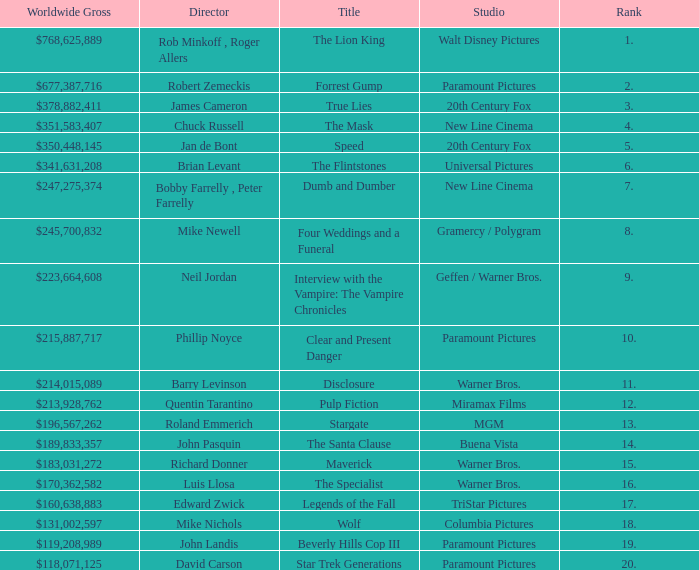Help me parse the entirety of this table. {'header': ['Worldwide Gross', 'Director', 'Title', 'Studio', 'Rank'], 'rows': [['$768,625,889', 'Rob Minkoff , Roger Allers', 'The Lion King', 'Walt Disney Pictures', '1.'], ['$677,387,716', 'Robert Zemeckis', 'Forrest Gump', 'Paramount Pictures', '2.'], ['$378,882,411', 'James Cameron', 'True Lies', '20th Century Fox', '3.'], ['$351,583,407', 'Chuck Russell', 'The Mask', 'New Line Cinema', '4.'], ['$350,448,145', 'Jan de Bont', 'Speed', '20th Century Fox', '5.'], ['$341,631,208', 'Brian Levant', 'The Flintstones', 'Universal Pictures', '6.'], ['$247,275,374', 'Bobby Farrelly , Peter Farrelly', 'Dumb and Dumber', 'New Line Cinema', '7.'], ['$245,700,832', 'Mike Newell', 'Four Weddings and a Funeral', 'Gramercy / Polygram', '8.'], ['$223,664,608', 'Neil Jordan', 'Interview with the Vampire: The Vampire Chronicles', 'Geffen / Warner Bros.', '9.'], ['$215,887,717', 'Phillip Noyce', 'Clear and Present Danger', 'Paramount Pictures', '10.'], ['$214,015,089', 'Barry Levinson', 'Disclosure', 'Warner Bros.', '11.'], ['$213,928,762', 'Quentin Tarantino', 'Pulp Fiction', 'Miramax Films', '12.'], ['$196,567,262', 'Roland Emmerich', 'Stargate', 'MGM', '13.'], ['$189,833,357', 'John Pasquin', 'The Santa Clause', 'Buena Vista', '14.'], ['$183,031,272', 'Richard Donner', 'Maverick', 'Warner Bros.', '15.'], ['$170,362,582', 'Luis Llosa', 'The Specialist', 'Warner Bros.', '16.'], ['$160,638,883', 'Edward Zwick', 'Legends of the Fall', 'TriStar Pictures', '17.'], ['$131,002,597', 'Mike Nichols', 'Wolf', 'Columbia Pictures', '18.'], ['$119,208,989', 'John Landis', 'Beverly Hills Cop III', 'Paramount Pictures', '19.'], ['$118,071,125', 'David Carson', 'Star Trek Generations', 'Paramount Pictures', '20.']]} What is the Rank of the Film with a Worldwide Gross of $183,031,272? 15.0. 